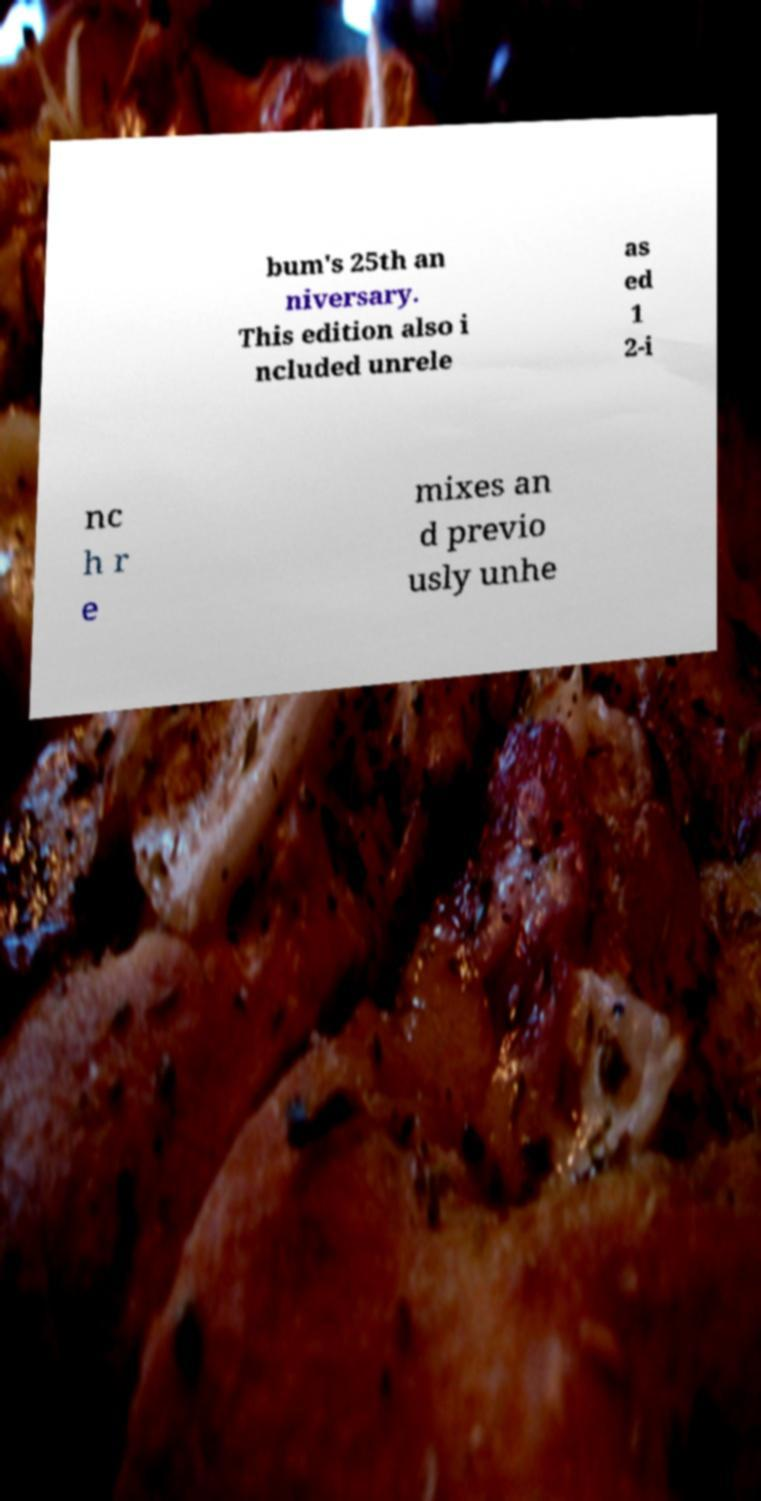For documentation purposes, I need the text within this image transcribed. Could you provide that? bum's 25th an niversary. This edition also i ncluded unrele as ed 1 2-i nc h r e mixes an d previo usly unhe 